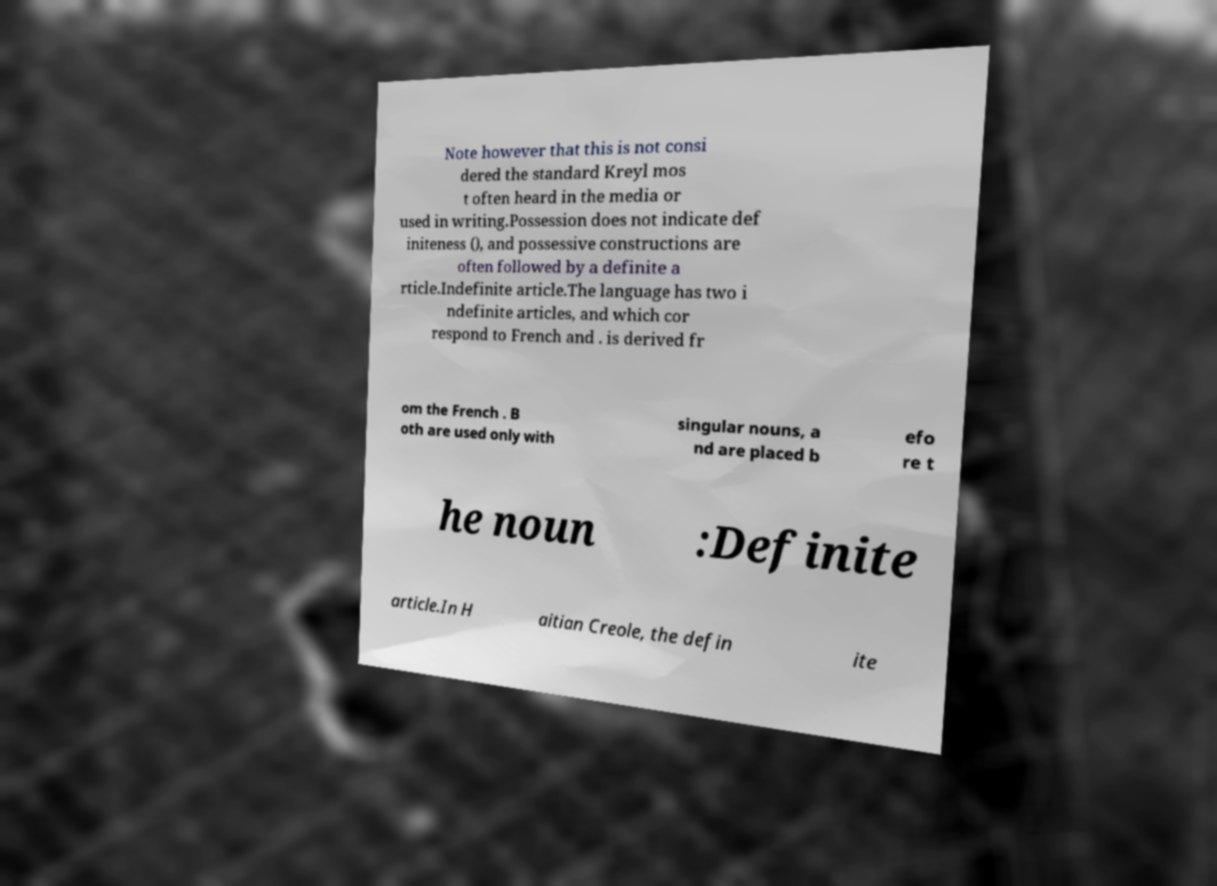Can you read and provide the text displayed in the image?This photo seems to have some interesting text. Can you extract and type it out for me? Note however that this is not consi dered the standard Kreyl mos t often heard in the media or used in writing.Possession does not indicate def initeness (), and possessive constructions are often followed by a definite a rticle.Indefinite article.The language has two i ndefinite articles, and which cor respond to French and . is derived fr om the French . B oth are used only with singular nouns, a nd are placed b efo re t he noun :Definite article.In H aitian Creole, the defin ite 